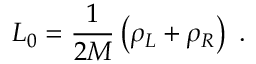Convert formula to latex. <formula><loc_0><loc_0><loc_500><loc_500>L _ { 0 } = \frac { 1 } { 2 M } \left ( \rho _ { L } + \rho _ { R } \right ) \ .</formula> 